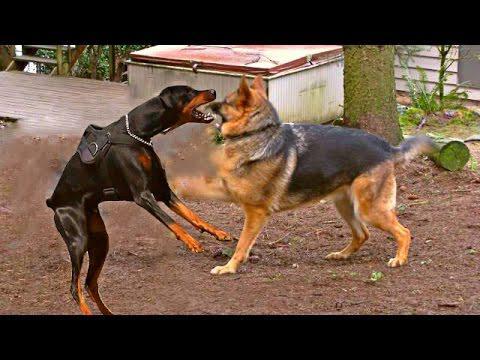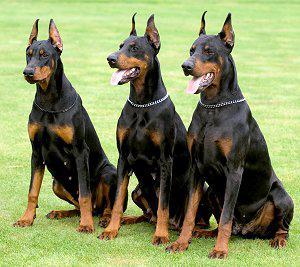The first image is the image on the left, the second image is the image on the right. Given the left and right images, does the statement "There are exactly two dogs." hold true? Answer yes or no. No. The first image is the image on the left, the second image is the image on the right. Evaluate the accuracy of this statement regarding the images: "There are only two dogs.". Is it true? Answer yes or no. No. 